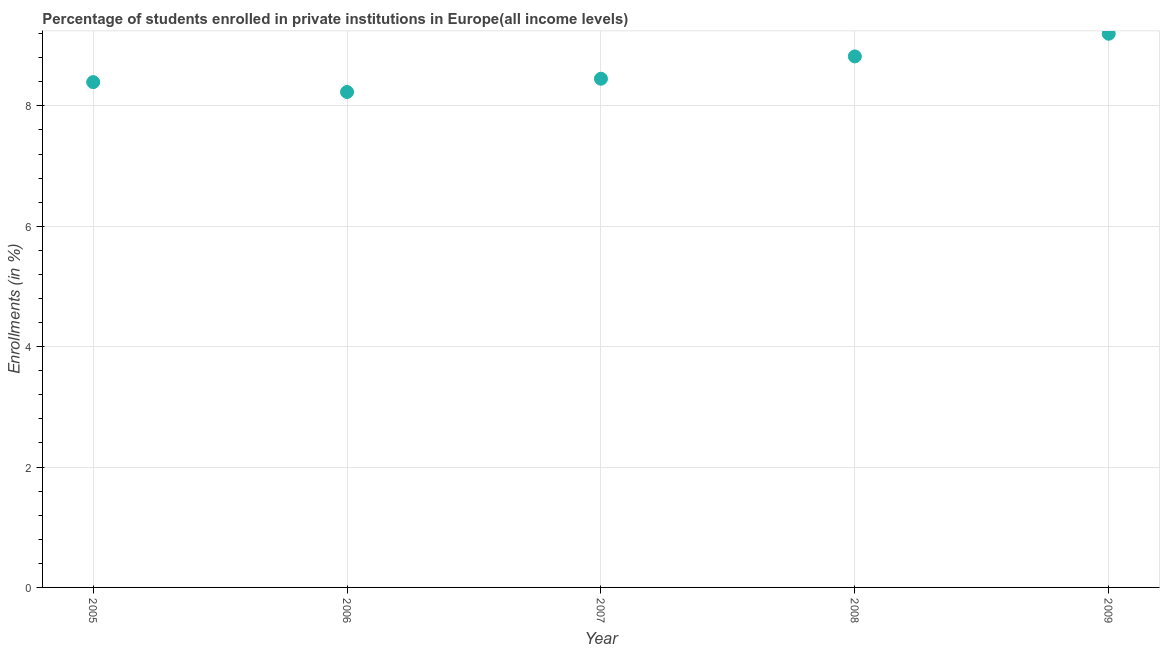What is the enrollments in private institutions in 2005?
Keep it short and to the point. 8.39. Across all years, what is the maximum enrollments in private institutions?
Provide a short and direct response. 9.2. Across all years, what is the minimum enrollments in private institutions?
Provide a succinct answer. 8.23. In which year was the enrollments in private institutions maximum?
Ensure brevity in your answer.  2009. What is the sum of the enrollments in private institutions?
Keep it short and to the point. 43.1. What is the difference between the enrollments in private institutions in 2008 and 2009?
Make the answer very short. -0.38. What is the average enrollments in private institutions per year?
Your answer should be compact. 8.62. What is the median enrollments in private institutions?
Offer a terse response. 8.45. In how many years, is the enrollments in private institutions greater than 5.6 %?
Offer a terse response. 5. Do a majority of the years between 2005 and 2007 (inclusive) have enrollments in private institutions greater than 6.8 %?
Ensure brevity in your answer.  Yes. What is the ratio of the enrollments in private institutions in 2006 to that in 2007?
Offer a very short reply. 0.97. Is the difference between the enrollments in private institutions in 2005 and 2009 greater than the difference between any two years?
Offer a very short reply. No. What is the difference between the highest and the second highest enrollments in private institutions?
Offer a terse response. 0.38. What is the difference between the highest and the lowest enrollments in private institutions?
Ensure brevity in your answer.  0.97. In how many years, is the enrollments in private institutions greater than the average enrollments in private institutions taken over all years?
Offer a terse response. 2. How many dotlines are there?
Offer a terse response. 1. Are the values on the major ticks of Y-axis written in scientific E-notation?
Your response must be concise. No. Does the graph contain any zero values?
Keep it short and to the point. No. What is the title of the graph?
Provide a short and direct response. Percentage of students enrolled in private institutions in Europe(all income levels). What is the label or title of the Y-axis?
Your response must be concise. Enrollments (in %). What is the Enrollments (in %) in 2005?
Give a very brief answer. 8.39. What is the Enrollments (in %) in 2006?
Your response must be concise. 8.23. What is the Enrollments (in %) in 2007?
Your answer should be compact. 8.45. What is the Enrollments (in %) in 2008?
Provide a short and direct response. 8.82. What is the Enrollments (in %) in 2009?
Provide a succinct answer. 9.2. What is the difference between the Enrollments (in %) in 2005 and 2006?
Your answer should be very brief. 0.16. What is the difference between the Enrollments (in %) in 2005 and 2007?
Make the answer very short. -0.06. What is the difference between the Enrollments (in %) in 2005 and 2008?
Give a very brief answer. -0.43. What is the difference between the Enrollments (in %) in 2005 and 2009?
Provide a succinct answer. -0.8. What is the difference between the Enrollments (in %) in 2006 and 2007?
Your response must be concise. -0.22. What is the difference between the Enrollments (in %) in 2006 and 2008?
Provide a short and direct response. -0.59. What is the difference between the Enrollments (in %) in 2006 and 2009?
Make the answer very short. -0.97. What is the difference between the Enrollments (in %) in 2007 and 2008?
Ensure brevity in your answer.  -0.37. What is the difference between the Enrollments (in %) in 2007 and 2009?
Provide a short and direct response. -0.75. What is the difference between the Enrollments (in %) in 2008 and 2009?
Ensure brevity in your answer.  -0.38. What is the ratio of the Enrollments (in %) in 2005 to that in 2009?
Provide a succinct answer. 0.91. What is the ratio of the Enrollments (in %) in 2006 to that in 2008?
Your answer should be compact. 0.93. What is the ratio of the Enrollments (in %) in 2006 to that in 2009?
Ensure brevity in your answer.  0.9. What is the ratio of the Enrollments (in %) in 2007 to that in 2008?
Give a very brief answer. 0.96. What is the ratio of the Enrollments (in %) in 2007 to that in 2009?
Provide a succinct answer. 0.92. What is the ratio of the Enrollments (in %) in 2008 to that in 2009?
Provide a short and direct response. 0.96. 